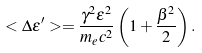Convert formula to latex. <formula><loc_0><loc_0><loc_500><loc_500>< \Delta \epsilon ^ { \prime } > = \frac { \gamma ^ { 2 } \epsilon ^ { 2 } } { m _ { e } c ^ { 2 } } \left ( 1 + \frac { \beta ^ { 2 } } { 2 } \right ) .</formula> 